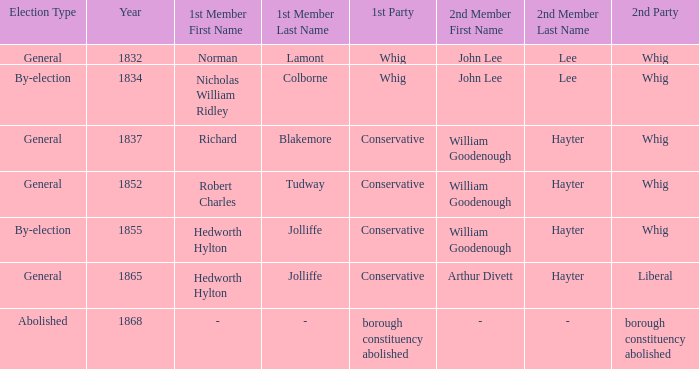Who's the traditionalist 1st participant in the election of 1852? Robert Charles Tudway. 